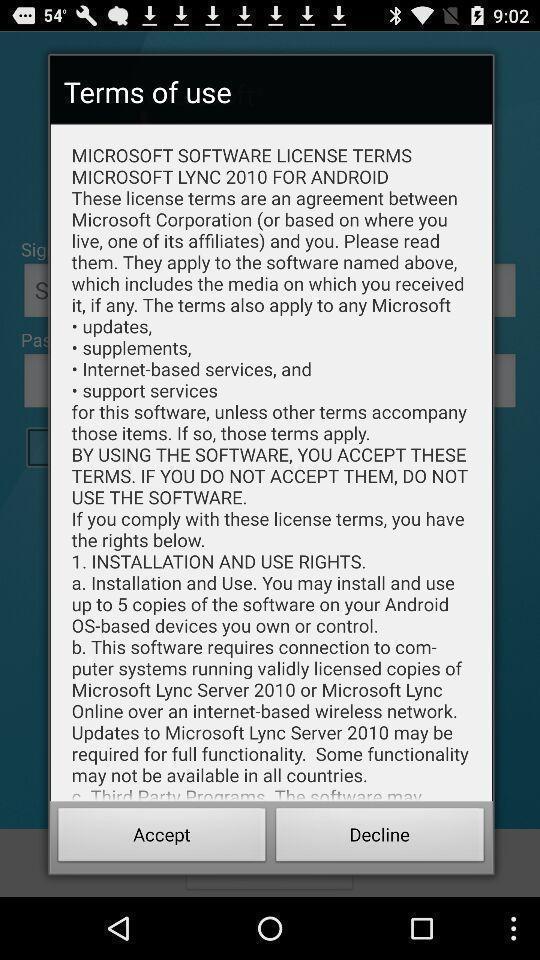Tell me what you see in this picture. Pop-up showing to accept terms to use. 